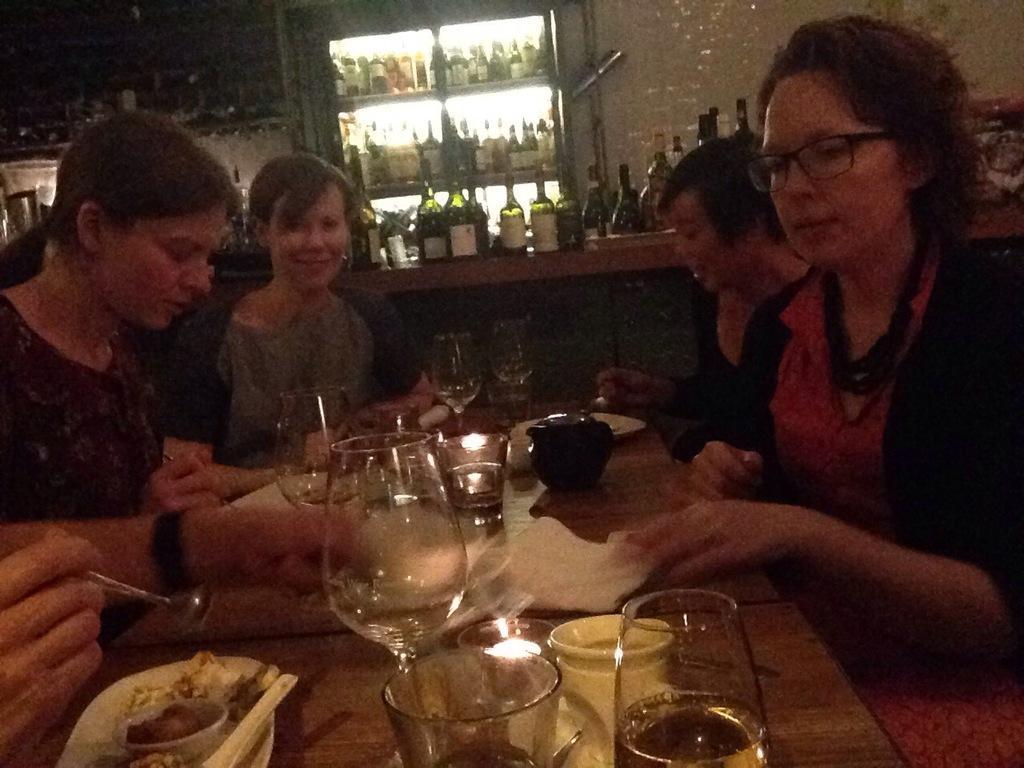Can you describe this image briefly? In this image I can see a group of people are sitting on a chair in front of a table. On the table we have a couple of glasses and other objects on it. 